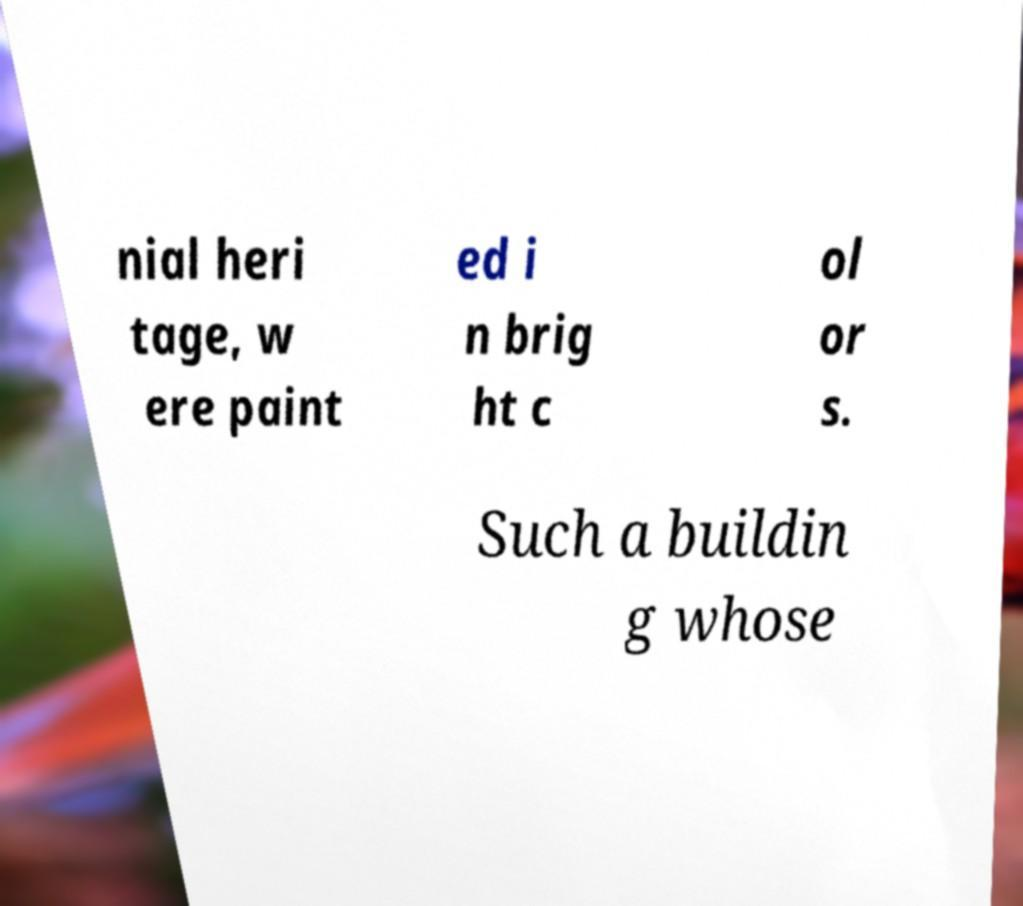Can you accurately transcribe the text from the provided image for me? nial heri tage, w ere paint ed i n brig ht c ol or s. Such a buildin g whose 